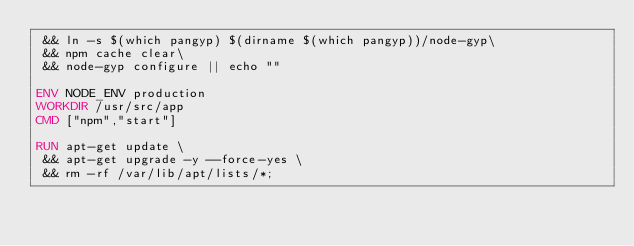Convert code to text. <code><loc_0><loc_0><loc_500><loc_500><_Dockerfile_> && ln -s $(which pangyp) $(dirname $(which pangyp))/node-gyp\
 && npm cache clear\
 && node-gyp configure || echo ""

ENV NODE_ENV production
WORKDIR /usr/src/app
CMD ["npm","start"]

RUN apt-get update \
 && apt-get upgrade -y --force-yes \
 && rm -rf /var/lib/apt/lists/*;</code> 